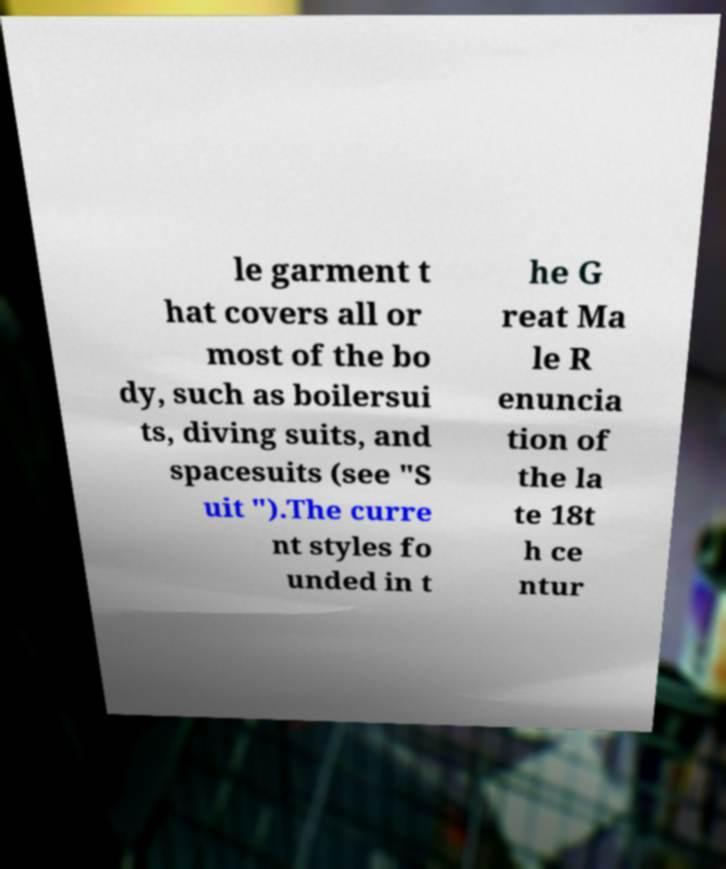There's text embedded in this image that I need extracted. Can you transcribe it verbatim? le garment t hat covers all or most of the bo dy, such as boilersui ts, diving suits, and spacesuits (see "S uit ").The curre nt styles fo unded in t he G reat Ma le R enuncia tion of the la te 18t h ce ntur 